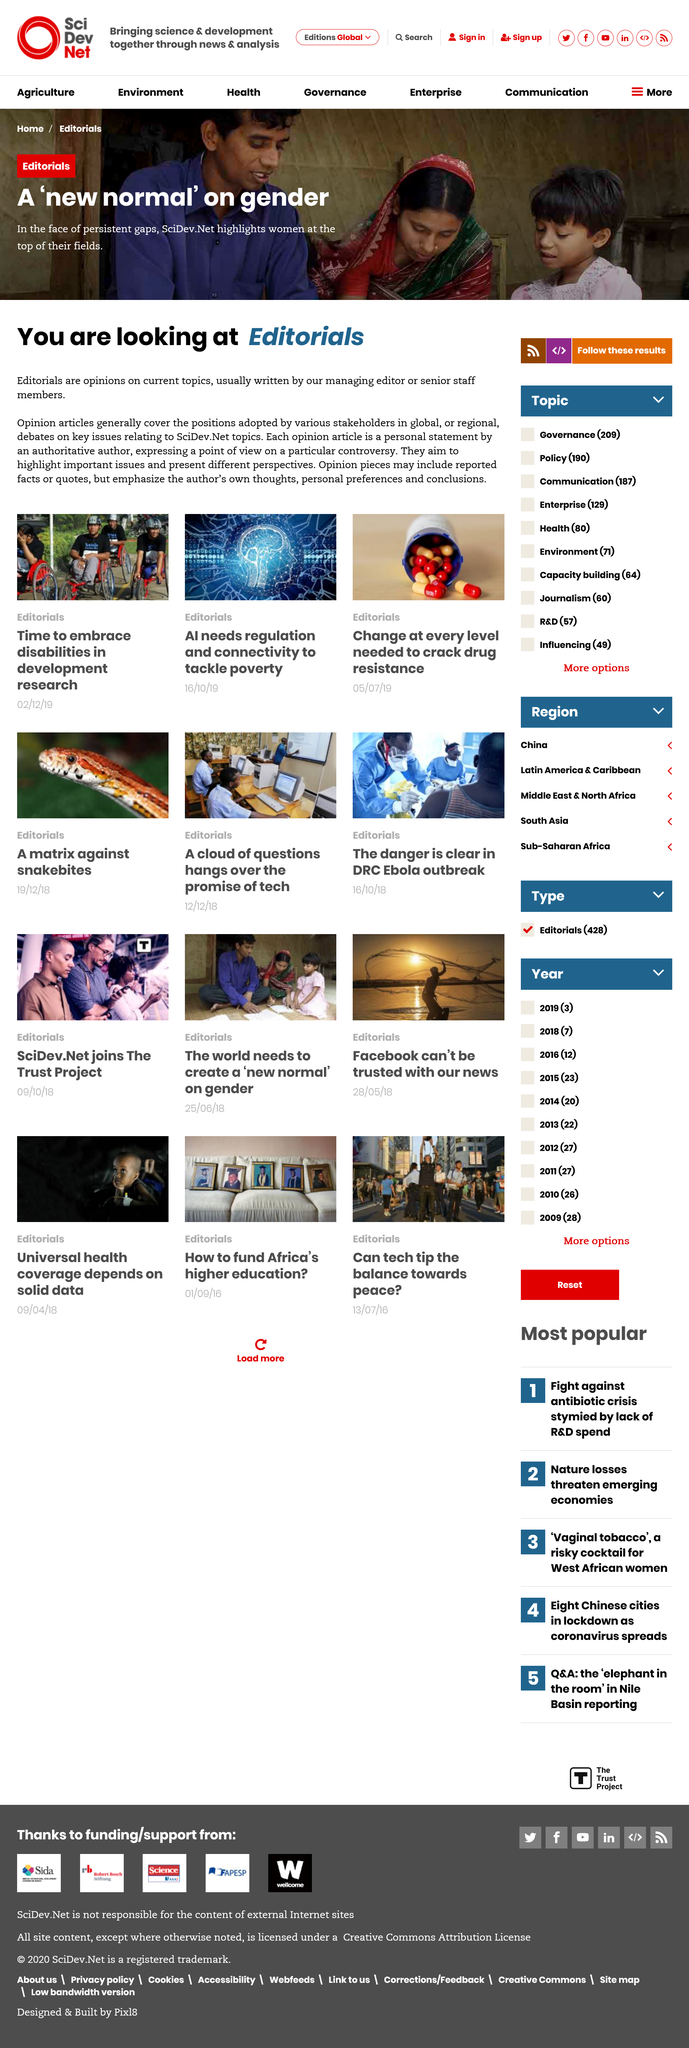Point out several critical features in this image. It is the responsibility of the managing editor or senior staff members to write pieces for editorials. The topic covered in the above issue of Editorials is a 'new normal' on gender, which talks to women at the top of their fields. It is a fact that the opinions expressed in editorials on current topics by stakeholders in global or regional debates are indeed opinions on current topics by stakeholders in global or regional debates. 